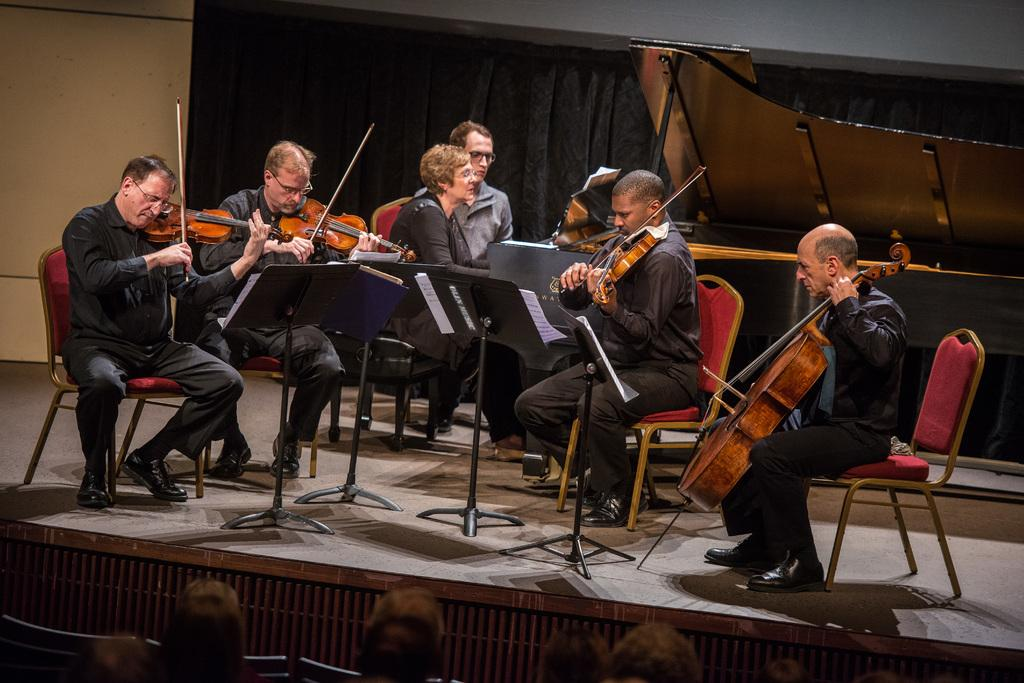What are the persons in the image doing? Some of the persons are sitting on chairs, and some are playing musical instruments. Where are the musical instruments located? The musical instruments are on a stage. What can be seen on the stage besides the musical instruments? There are stands on the stage. What is visible in the background of the image? There is a curtain and a wall in the background. Is there any cake visible in the image? No, there is no cake present in the image. Is it raining in the image? No, there is no indication of rain in the image. 